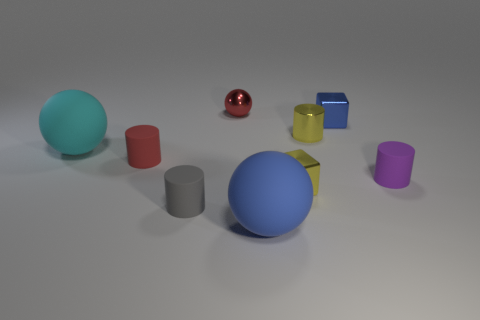How many other objects are the same size as the yellow cylinder?
Offer a very short reply. 6. There is a blue matte object; is its size the same as the block that is behind the small yellow shiny cylinder?
Make the answer very short. No. What shape is the tiny matte object that is in front of the yellow metallic object in front of the matte sphere that is to the left of the gray matte cylinder?
Offer a terse response. Cylinder. Are there fewer big blue shiny spheres than rubber cylinders?
Your response must be concise. Yes. Are there any blue spheres behind the large cyan rubber object?
Provide a short and direct response. No. What is the shape of the object that is both behind the red cylinder and on the left side of the tiny gray matte cylinder?
Ensure brevity in your answer.  Sphere. Is there a small red thing of the same shape as the big blue rubber thing?
Provide a succinct answer. Yes. Does the matte ball that is right of the big cyan matte sphere have the same size as the yellow object in front of the purple cylinder?
Provide a succinct answer. No. Is the number of big gray rubber objects greater than the number of large things?
Your answer should be compact. No. How many other objects have the same material as the large blue object?
Offer a very short reply. 4. 